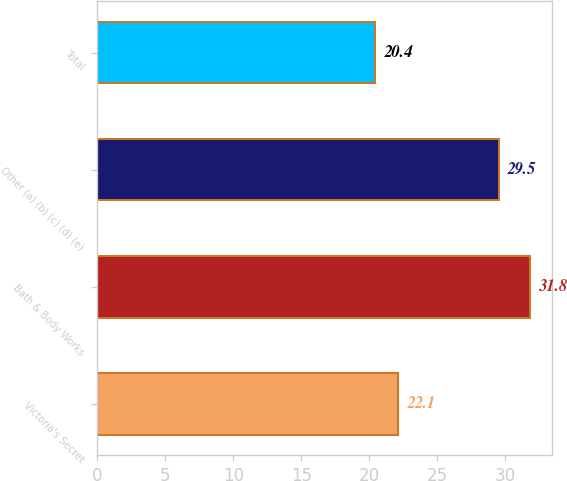Convert chart. <chart><loc_0><loc_0><loc_500><loc_500><bar_chart><fcel>Victoria's Secret<fcel>Bath & Body Works<fcel>Other (a) (b) (c) (d) (e)<fcel>Total<nl><fcel>22.1<fcel>31.8<fcel>29.5<fcel>20.4<nl></chart> 